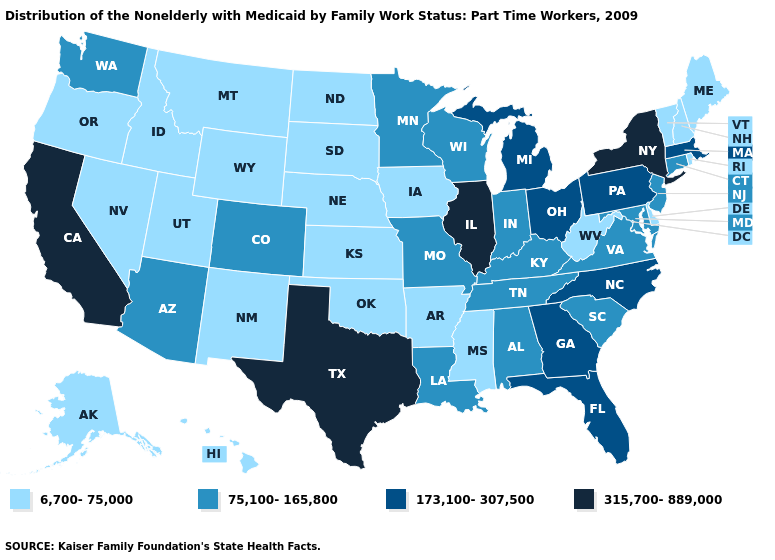Which states have the lowest value in the USA?
Answer briefly. Alaska, Arkansas, Delaware, Hawaii, Idaho, Iowa, Kansas, Maine, Mississippi, Montana, Nebraska, Nevada, New Hampshire, New Mexico, North Dakota, Oklahoma, Oregon, Rhode Island, South Dakota, Utah, Vermont, West Virginia, Wyoming. Which states have the lowest value in the MidWest?
Write a very short answer. Iowa, Kansas, Nebraska, North Dakota, South Dakota. Which states have the lowest value in the USA?
Concise answer only. Alaska, Arkansas, Delaware, Hawaii, Idaho, Iowa, Kansas, Maine, Mississippi, Montana, Nebraska, Nevada, New Hampshire, New Mexico, North Dakota, Oklahoma, Oregon, Rhode Island, South Dakota, Utah, Vermont, West Virginia, Wyoming. Name the states that have a value in the range 75,100-165,800?
Quick response, please. Alabama, Arizona, Colorado, Connecticut, Indiana, Kentucky, Louisiana, Maryland, Minnesota, Missouri, New Jersey, South Carolina, Tennessee, Virginia, Washington, Wisconsin. What is the value of South Dakota?
Keep it brief. 6,700-75,000. Which states have the lowest value in the West?
Quick response, please. Alaska, Hawaii, Idaho, Montana, Nevada, New Mexico, Oregon, Utah, Wyoming. What is the value of Arizona?
Keep it brief. 75,100-165,800. Which states have the highest value in the USA?
Concise answer only. California, Illinois, New York, Texas. Which states have the lowest value in the USA?
Answer briefly. Alaska, Arkansas, Delaware, Hawaii, Idaho, Iowa, Kansas, Maine, Mississippi, Montana, Nebraska, Nevada, New Hampshire, New Mexico, North Dakota, Oklahoma, Oregon, Rhode Island, South Dakota, Utah, Vermont, West Virginia, Wyoming. How many symbols are there in the legend?
Quick response, please. 4. Name the states that have a value in the range 6,700-75,000?
Be succinct. Alaska, Arkansas, Delaware, Hawaii, Idaho, Iowa, Kansas, Maine, Mississippi, Montana, Nebraska, Nevada, New Hampshire, New Mexico, North Dakota, Oklahoma, Oregon, Rhode Island, South Dakota, Utah, Vermont, West Virginia, Wyoming. Does Maine have the lowest value in the USA?
Short answer required. Yes. What is the value of Alaska?
Answer briefly. 6,700-75,000. Name the states that have a value in the range 315,700-889,000?
Answer briefly. California, Illinois, New York, Texas. Does Illinois have the lowest value in the MidWest?
Give a very brief answer. No. 